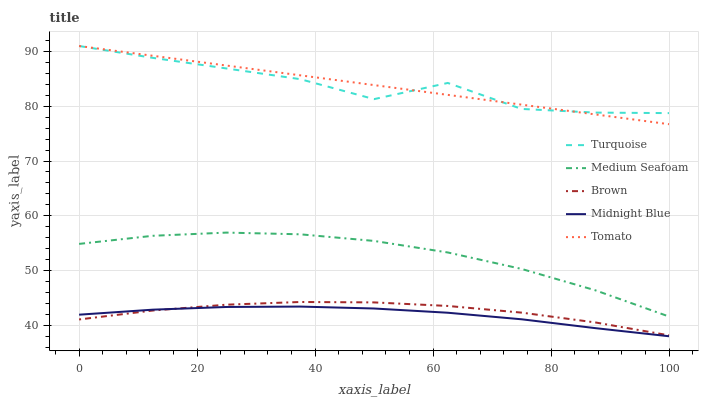Does Midnight Blue have the minimum area under the curve?
Answer yes or no. Yes. Does Tomato have the maximum area under the curve?
Answer yes or no. Yes. Does Brown have the minimum area under the curve?
Answer yes or no. No. Does Brown have the maximum area under the curve?
Answer yes or no. No. Is Tomato the smoothest?
Answer yes or no. Yes. Is Turquoise the roughest?
Answer yes or no. Yes. Is Brown the smoothest?
Answer yes or no. No. Is Brown the roughest?
Answer yes or no. No. Does Midnight Blue have the lowest value?
Answer yes or no. Yes. Does Brown have the lowest value?
Answer yes or no. No. Does Turquoise have the highest value?
Answer yes or no. Yes. Does Brown have the highest value?
Answer yes or no. No. Is Midnight Blue less than Tomato?
Answer yes or no. Yes. Is Turquoise greater than Brown?
Answer yes or no. Yes. Does Tomato intersect Turquoise?
Answer yes or no. Yes. Is Tomato less than Turquoise?
Answer yes or no. No. Is Tomato greater than Turquoise?
Answer yes or no. No. Does Midnight Blue intersect Tomato?
Answer yes or no. No. 